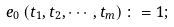<formula> <loc_0><loc_0><loc_500><loc_500>e _ { 0 } \left ( t _ { 1 } , t _ { 2 } , \cdots , t _ { m } \right ) \colon = 1 ;</formula> 